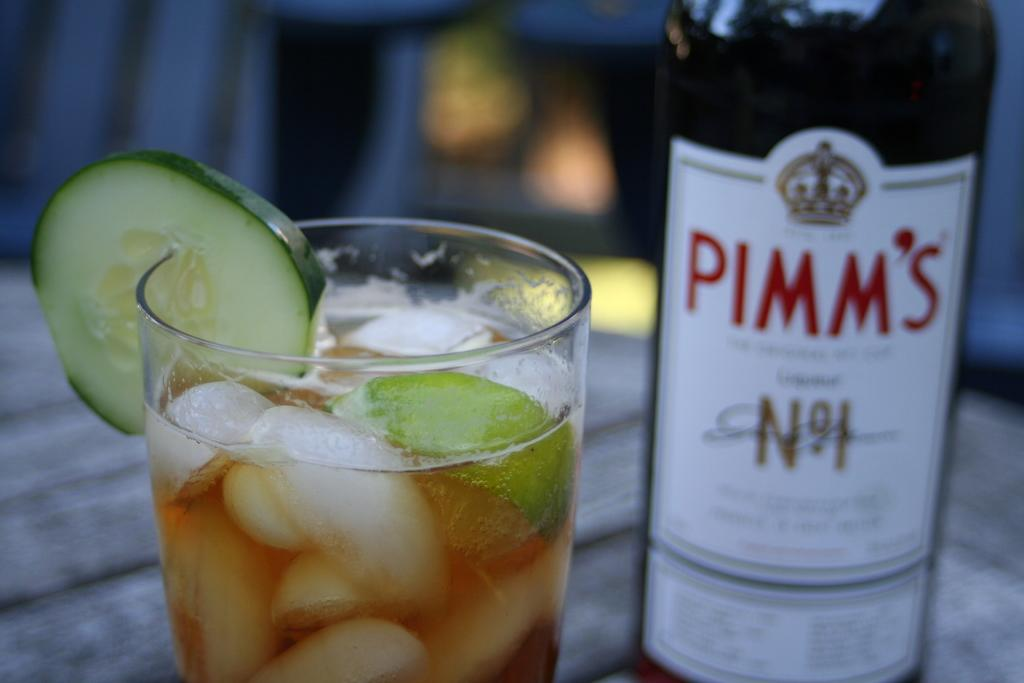<image>
Summarize the visual content of the image. A cocktail sits on a table in front of a bottle of Pimm's. 